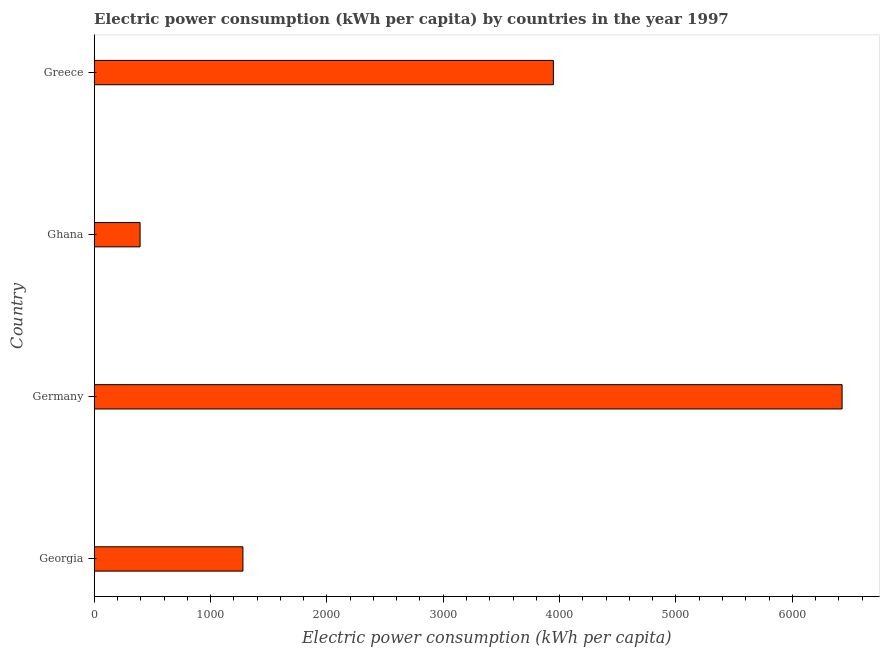Does the graph contain grids?
Make the answer very short. No. What is the title of the graph?
Give a very brief answer. Electric power consumption (kWh per capita) by countries in the year 1997. What is the label or title of the X-axis?
Your response must be concise. Electric power consumption (kWh per capita). What is the electric power consumption in Germany?
Your answer should be very brief. 6427.8. Across all countries, what is the maximum electric power consumption?
Give a very brief answer. 6427.8. Across all countries, what is the minimum electric power consumption?
Keep it short and to the point. 394.28. In which country was the electric power consumption minimum?
Provide a short and direct response. Ghana. What is the sum of the electric power consumption?
Your answer should be very brief. 1.20e+04. What is the difference between the electric power consumption in Georgia and Greece?
Offer a very short reply. -2668.32. What is the average electric power consumption per country?
Your response must be concise. 3011.67. What is the median electric power consumption?
Your response must be concise. 2612.3. In how many countries, is the electric power consumption greater than 2600 kWh per capita?
Keep it short and to the point. 2. What is the ratio of the electric power consumption in Ghana to that in Greece?
Your answer should be very brief. 0.1. Is the electric power consumption in Germany less than that in Ghana?
Your response must be concise. No. What is the difference between the highest and the second highest electric power consumption?
Ensure brevity in your answer.  2481.34. What is the difference between the highest and the lowest electric power consumption?
Offer a terse response. 6033.52. In how many countries, is the electric power consumption greater than the average electric power consumption taken over all countries?
Make the answer very short. 2. How many bars are there?
Your response must be concise. 4. Are all the bars in the graph horizontal?
Your answer should be very brief. Yes. What is the difference between two consecutive major ticks on the X-axis?
Your response must be concise. 1000. Are the values on the major ticks of X-axis written in scientific E-notation?
Provide a succinct answer. No. What is the Electric power consumption (kWh per capita) in Georgia?
Your answer should be compact. 1278.14. What is the Electric power consumption (kWh per capita) of Germany?
Offer a very short reply. 6427.8. What is the Electric power consumption (kWh per capita) of Ghana?
Offer a very short reply. 394.28. What is the Electric power consumption (kWh per capita) of Greece?
Ensure brevity in your answer.  3946.46. What is the difference between the Electric power consumption (kWh per capita) in Georgia and Germany?
Ensure brevity in your answer.  -5149.66. What is the difference between the Electric power consumption (kWh per capita) in Georgia and Ghana?
Make the answer very short. 883.85. What is the difference between the Electric power consumption (kWh per capita) in Georgia and Greece?
Keep it short and to the point. -2668.32. What is the difference between the Electric power consumption (kWh per capita) in Germany and Ghana?
Offer a very short reply. 6033.52. What is the difference between the Electric power consumption (kWh per capita) in Germany and Greece?
Make the answer very short. 2481.34. What is the difference between the Electric power consumption (kWh per capita) in Ghana and Greece?
Offer a very short reply. -3552.17. What is the ratio of the Electric power consumption (kWh per capita) in Georgia to that in Germany?
Provide a succinct answer. 0.2. What is the ratio of the Electric power consumption (kWh per capita) in Georgia to that in Ghana?
Give a very brief answer. 3.24. What is the ratio of the Electric power consumption (kWh per capita) in Georgia to that in Greece?
Your response must be concise. 0.32. What is the ratio of the Electric power consumption (kWh per capita) in Germany to that in Ghana?
Offer a terse response. 16.3. What is the ratio of the Electric power consumption (kWh per capita) in Germany to that in Greece?
Give a very brief answer. 1.63. 